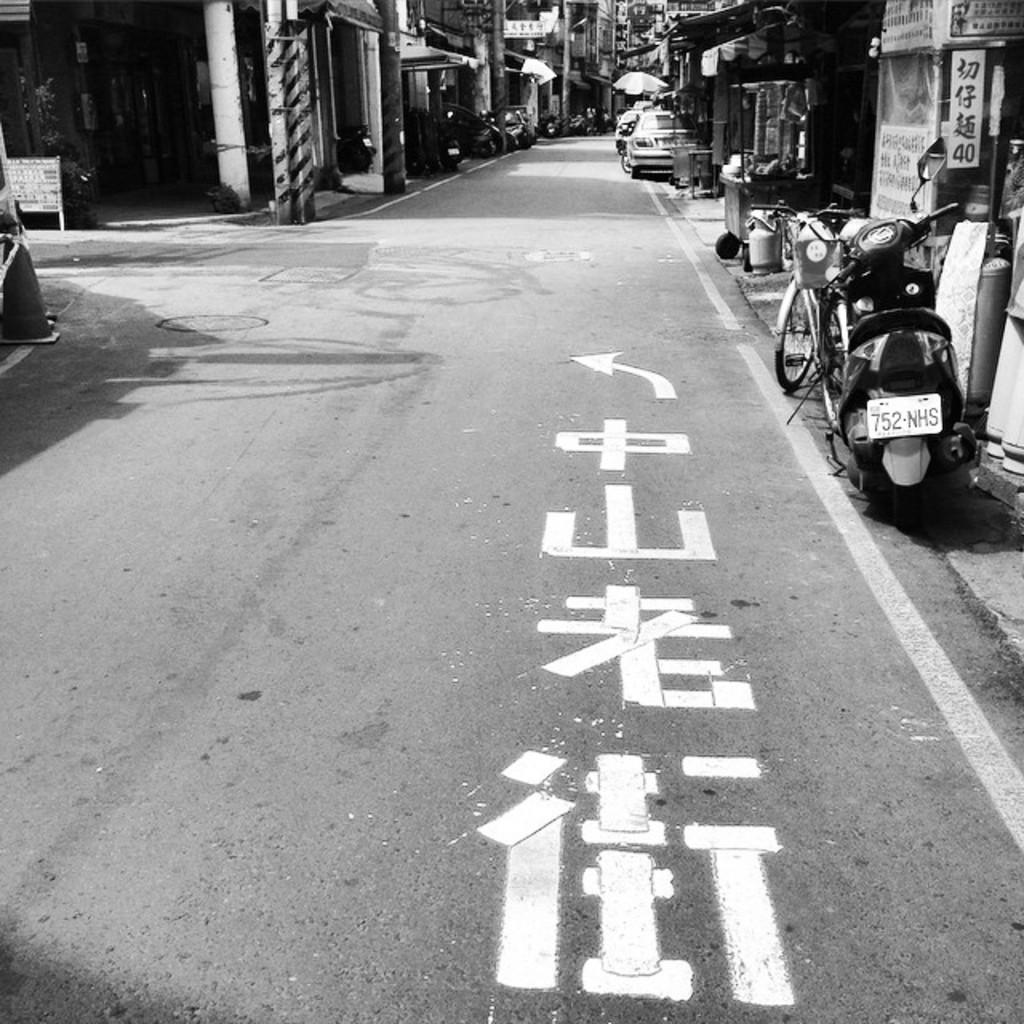What is the main feature of the image? The image contains a road. Can you describe the parked vehicle in the image? There is a parked vehicle on the right side of the road. What type of structures can be seen in the image? There are houses visible in the image. What type of board game is being played on the road in the image? There is no board game or any indication of a game being played in the image. 